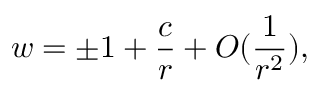<formula> <loc_0><loc_0><loc_500><loc_500>w = \pm 1 + \frac { c } { r } + O ( \frac { 1 } { r ^ { 2 } } ) ,</formula> 